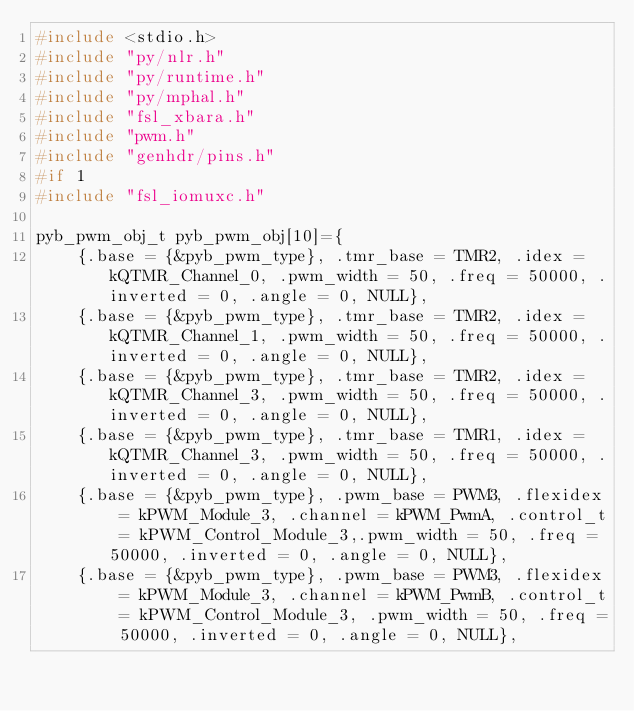Convert code to text. <code><loc_0><loc_0><loc_500><loc_500><_C_>#include <stdio.h>
#include "py/nlr.h"
#include "py/runtime.h"
#include "py/mphal.h"
#include "fsl_xbara.h"
#include "pwm.h"
#include "genhdr/pins.h"
#if 1
#include "fsl_iomuxc.h"

pyb_pwm_obj_t pyb_pwm_obj[10]={
	{.base = {&pyb_pwm_type}, .tmr_base = TMR2, .idex = kQTMR_Channel_0, .pwm_width = 50, .freq = 50000, .inverted = 0, .angle = 0, NULL},
	{.base = {&pyb_pwm_type}, .tmr_base = TMR2, .idex = kQTMR_Channel_1, .pwm_width = 50, .freq = 50000, .inverted = 0, .angle = 0, NULL},
	{.base = {&pyb_pwm_type}, .tmr_base = TMR2, .idex = kQTMR_Channel_3, .pwm_width = 50, .freq = 50000, .inverted = 0, .angle = 0, NULL},
	{.base = {&pyb_pwm_type}, .tmr_base = TMR1, .idex = kQTMR_Channel_3, .pwm_width = 50, .freq = 50000, .inverted = 0, .angle = 0, NULL},
	{.base = {&pyb_pwm_type}, .pwm_base = PWM3, .flexidex = kPWM_Module_3, .channel = kPWM_PwmA, .control_t = kPWM_Control_Module_3,.pwm_width = 50, .freq = 50000, .inverted = 0, .angle = 0, NULL},
	{.base = {&pyb_pwm_type}, .pwm_base = PWM3, .flexidex = kPWM_Module_3, .channel = kPWM_PwmB, .control_t = kPWM_Control_Module_3, .pwm_width = 50, .freq = 50000, .inverted = 0, .angle = 0, NULL},</code> 